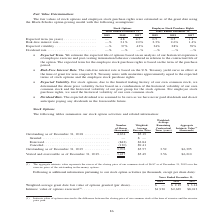According to A10 Networks's financial document, What is the number of outstanding shares granted as of December 31, 2018?  According to the financial document, 4,674 (in thousands). The relevant text states: "Outstanding as of December 31, 2018 . 4,674 $5.19 Granted . — $ — Exercised. . (842) $2.84 Canceled . (130) $9.41..." Also, What is the number of shares exercised as of December 31, 2018?  According to the financial document, (842) (in thousands). The relevant text states: "1, 2018 . 4,674 $5.19 Granted . — $ — Exercised. . (842) $2.84 Canceled . (130) $9.41..." Also, What is the number of shares canceled as of December 31, 2018?  According to the financial document, (130) (in thousands). The relevant text states: "ranted . — $ — Exercised. . (842) $2.84 Canceled . (130) $9.41..." Also, can you calculate: What is the total amount spent on the canceled shares? Based on the calculation: (130)* $9.41 , the result is -1223.3 (in thousands). This is based on the information: "— $ — Exercised. . (842) $2.84 Canceled . (130) $9.41 nted . — $ — Exercised. . (842) $2.84 Canceled . (130) $9.41..." The key data points involved are: 130, 9.41. Also, can you calculate: What is difference on the aggregate intrinsic value between Outstanding and Vested and exercisable as of December 31, 2019? Based on the calculation: $6,395-$6,210, the result is 185 (in thousands). This is based on the information: "able as of December 31, 2019. . 3,427 $5.49 3.56 $6,210 nding as of December 31, 2019 . 3,702 $5.57 3.52 $6,395..." The key data points involved are: 6,210, 6,395. Also, can you calculate: What is the difference in outstanding shares as of December 31, 2018 and 2019? Based on the calculation: 4,674 - 3,702 , the result is 972 (in thousands). This is based on the information: "Outstanding as of December 31, 2019 . 3,702 $5.57 3.52 $6,395 Outstanding as of December 31, 2018 . 4,674 $5.19 Granted . — $ — Exercised. . (842) $2.84 Canceled . (130) $9.41..." The key data points involved are: 3,702, 4,674. 